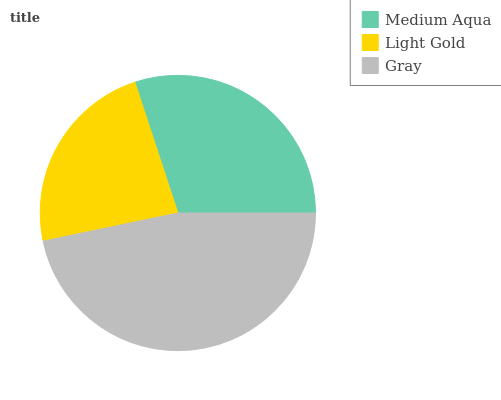Is Light Gold the minimum?
Answer yes or no. Yes. Is Gray the maximum?
Answer yes or no. Yes. Is Gray the minimum?
Answer yes or no. No. Is Light Gold the maximum?
Answer yes or no. No. Is Gray greater than Light Gold?
Answer yes or no. Yes. Is Light Gold less than Gray?
Answer yes or no. Yes. Is Light Gold greater than Gray?
Answer yes or no. No. Is Gray less than Light Gold?
Answer yes or no. No. Is Medium Aqua the high median?
Answer yes or no. Yes. Is Medium Aqua the low median?
Answer yes or no. Yes. Is Gray the high median?
Answer yes or no. No. Is Light Gold the low median?
Answer yes or no. No. 